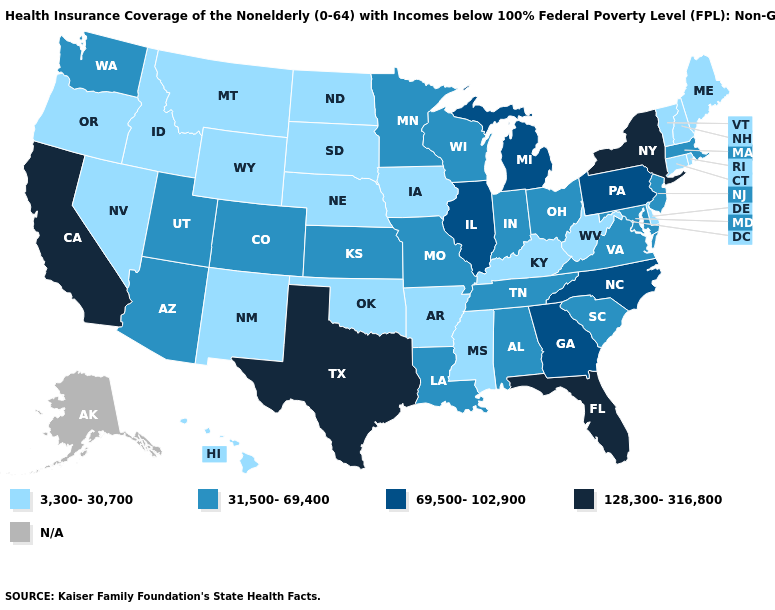What is the value of Tennessee?
Write a very short answer. 31,500-69,400. What is the highest value in the USA?
Concise answer only. 128,300-316,800. Among the states that border Virginia , which have the highest value?
Quick response, please. North Carolina. What is the value of Virginia?
Be succinct. 31,500-69,400. Which states have the lowest value in the Northeast?
Keep it brief. Connecticut, Maine, New Hampshire, Rhode Island, Vermont. What is the lowest value in states that border Indiana?
Short answer required. 3,300-30,700. Which states have the lowest value in the USA?
Be succinct. Arkansas, Connecticut, Delaware, Hawaii, Idaho, Iowa, Kentucky, Maine, Mississippi, Montana, Nebraska, Nevada, New Hampshire, New Mexico, North Dakota, Oklahoma, Oregon, Rhode Island, South Dakota, Vermont, West Virginia, Wyoming. What is the value of West Virginia?
Keep it brief. 3,300-30,700. Does California have the highest value in the USA?
Be succinct. Yes. Among the states that border Arizona , does California have the highest value?
Concise answer only. Yes. Name the states that have a value in the range 31,500-69,400?
Concise answer only. Alabama, Arizona, Colorado, Indiana, Kansas, Louisiana, Maryland, Massachusetts, Minnesota, Missouri, New Jersey, Ohio, South Carolina, Tennessee, Utah, Virginia, Washington, Wisconsin. Name the states that have a value in the range 69,500-102,900?
Concise answer only. Georgia, Illinois, Michigan, North Carolina, Pennsylvania. Name the states that have a value in the range 69,500-102,900?
Answer briefly. Georgia, Illinois, Michigan, North Carolina, Pennsylvania. Among the states that border Oregon , which have the lowest value?
Keep it brief. Idaho, Nevada. 